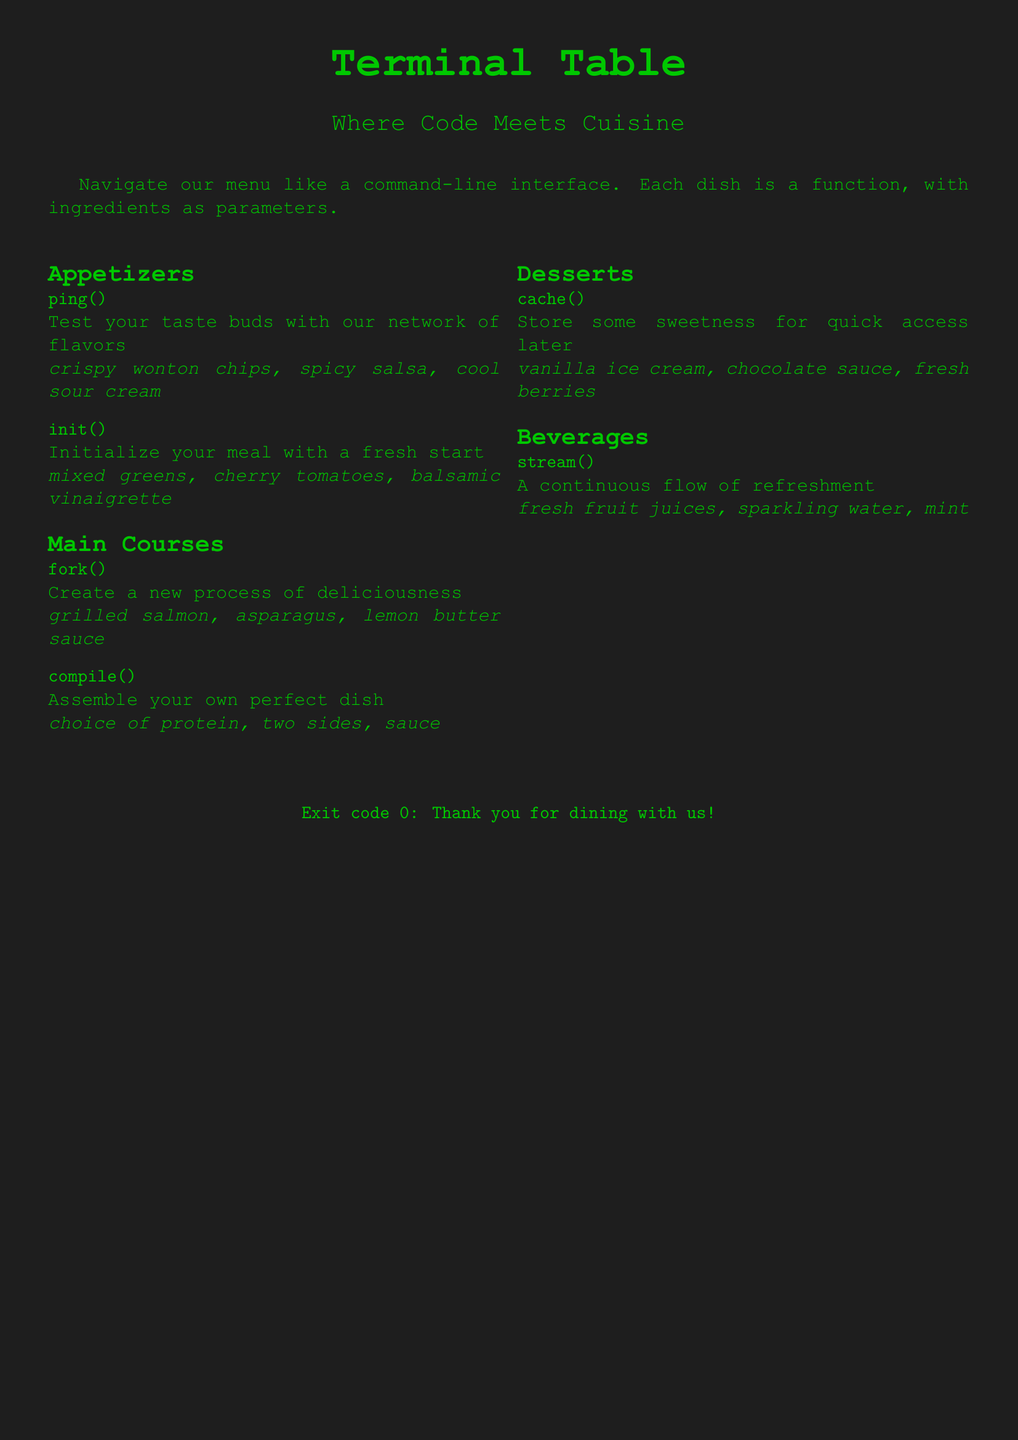What is the name of the restaurant? The name of the restaurant is presented at the top of the document, highlighted in a title format.
Answer: Terminal Table What is an example of an appetizer? The document lists appetizers under a specific section; an example is given explicitly.
Answer: ping() What ingredients are in the dish "fork()"? The ingredients for the dish "fork()" are detailed directly following its description in the document.
Answer: grilled salmon, asparagus, lemon butter sauce What dessert can be "cached"? This question seeks the specific dessert mentioned in the dessert section of the menu.
Answer: cache() What type of beverages does "stream()" offer? The types of beverages are specified directly with the command.
Answer: fresh fruit juices, sparkling water, mint Which dish requires a choice of protein? This question refers to the dish described in the main courses that mentions protein explicitly.
Answer: compile() What are the main colors used in the menu? The color specifications of the document highlight the overall theme and appearance of the menu.
Answer: terminal green, terminal black What is the closing message of the menu? This message is printed at the end of the document and serves as a way to thank customers.
Answer: Exit code 0: Thank you for dining with us! 